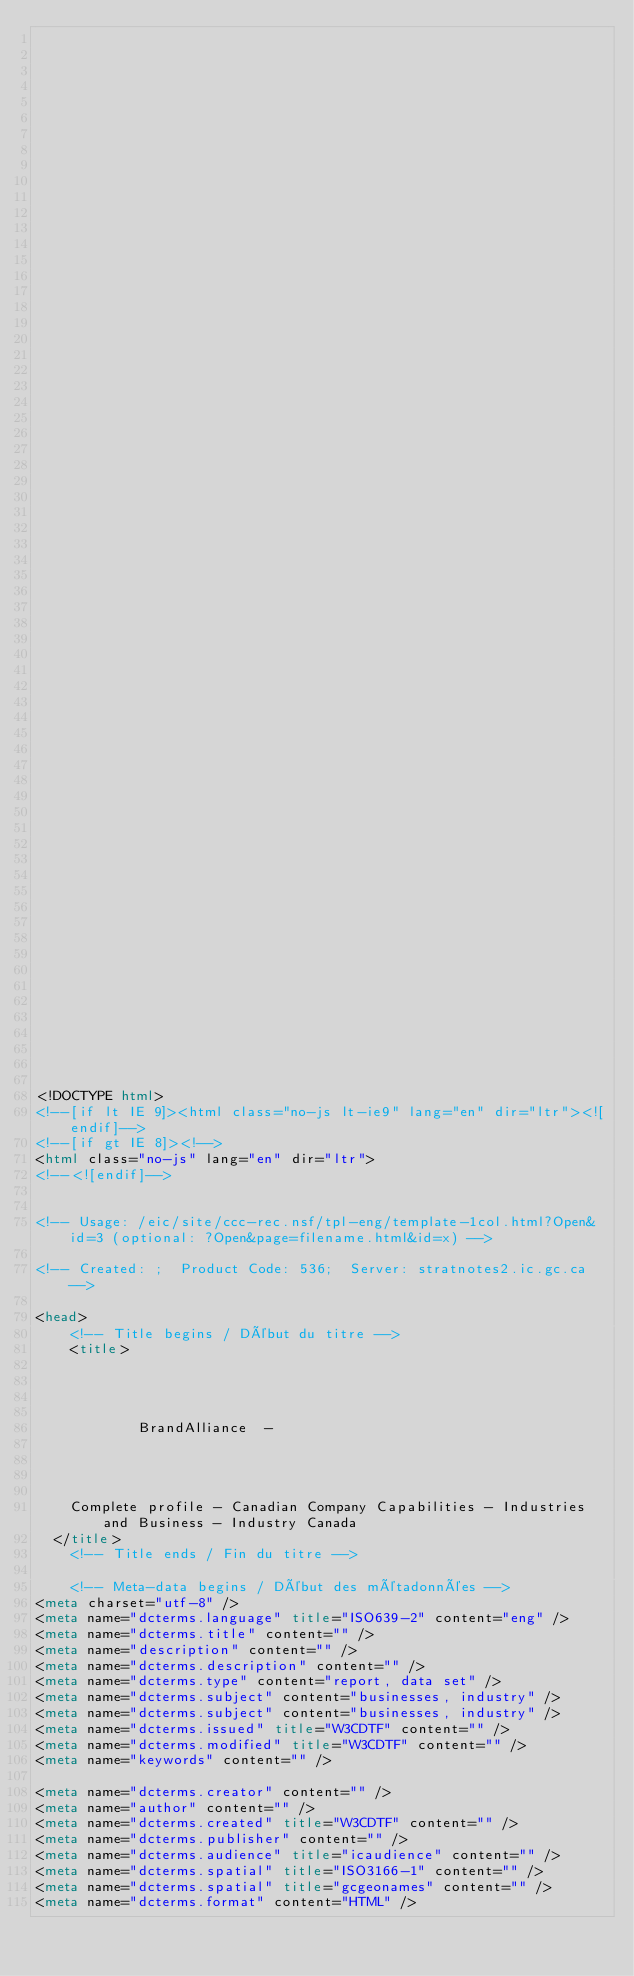Convert code to text. <code><loc_0><loc_0><loc_500><loc_500><_HTML_>


















	






  
  
  
  































	
	
	



<!DOCTYPE html>
<!--[if lt IE 9]><html class="no-js lt-ie9" lang="en" dir="ltr"><![endif]-->
<!--[if gt IE 8]><!-->
<html class="no-js" lang="en" dir="ltr">
<!--<![endif]-->


<!-- Usage: /eic/site/ccc-rec.nsf/tpl-eng/template-1col.html?Open&id=3 (optional: ?Open&page=filename.html&id=x) -->

<!-- Created: ;  Product Code: 536;  Server: stratnotes2.ic.gc.ca -->

<head>
	<!-- Title begins / Début du titre -->
	<title>
    
            
        
          
            BrandAlliance  -
          
        
      
    
    Complete profile - Canadian Company Capabilities - Industries and Business - Industry Canada
  </title>
	<!-- Title ends / Fin du titre -->
 
	<!-- Meta-data begins / Début des métadonnées -->
<meta charset="utf-8" />
<meta name="dcterms.language" title="ISO639-2" content="eng" />
<meta name="dcterms.title" content="" />
<meta name="description" content="" />
<meta name="dcterms.description" content="" />
<meta name="dcterms.type" content="report, data set" />
<meta name="dcterms.subject" content="businesses, industry" />
<meta name="dcterms.subject" content="businesses, industry" />
<meta name="dcterms.issued" title="W3CDTF" content="" />
<meta name="dcterms.modified" title="W3CDTF" content="" />
<meta name="keywords" content="" />

<meta name="dcterms.creator" content="" />
<meta name="author" content="" />
<meta name="dcterms.created" title="W3CDTF" content="" />
<meta name="dcterms.publisher" content="" />
<meta name="dcterms.audience" title="icaudience" content="" />
<meta name="dcterms.spatial" title="ISO3166-1" content="" />
<meta name="dcterms.spatial" title="gcgeonames" content="" />
<meta name="dcterms.format" content="HTML" /></code> 